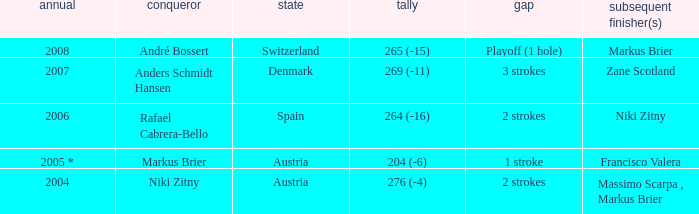Who was the runner-up when the margin was 1 stroke? Francisco Valera. 